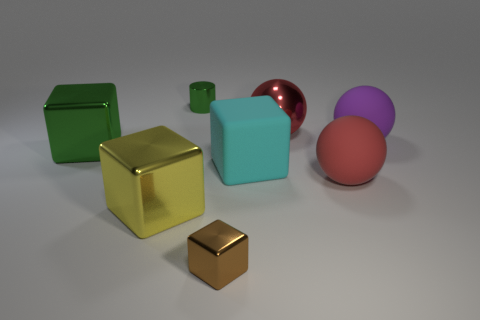Add 1 blue rubber blocks. How many objects exist? 9 Subtract all spheres. How many objects are left? 5 Add 3 green objects. How many green objects are left? 5 Add 7 tiny metal cylinders. How many tiny metal cylinders exist? 8 Subtract 0 blue blocks. How many objects are left? 8 Subtract all purple objects. Subtract all large cyan things. How many objects are left? 6 